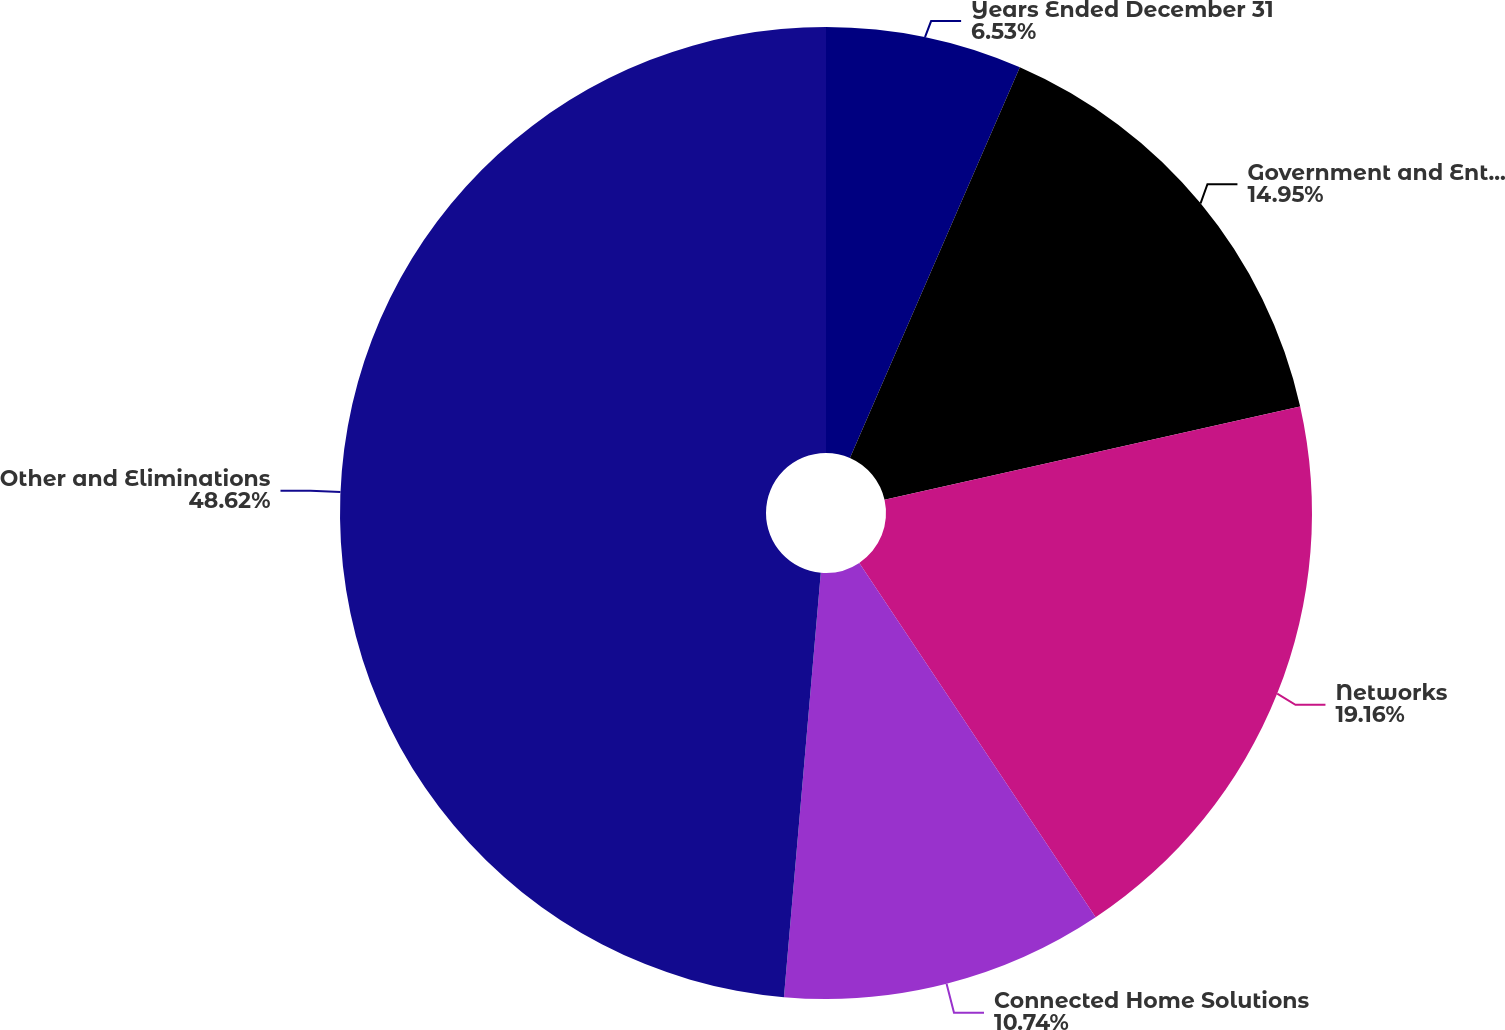<chart> <loc_0><loc_0><loc_500><loc_500><pie_chart><fcel>Years Ended December 31<fcel>Government and Enterprise<fcel>Networks<fcel>Connected Home Solutions<fcel>Other and Eliminations<nl><fcel>6.53%<fcel>14.95%<fcel>19.16%<fcel>10.74%<fcel>48.62%<nl></chart> 